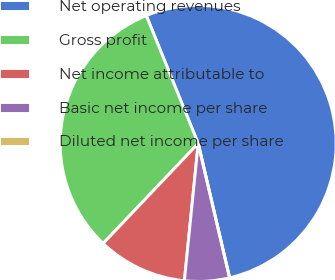<chart> <loc_0><loc_0><loc_500><loc_500><pie_chart><fcel>Net operating revenues<fcel>Gross profit<fcel>Net income attributable to<fcel>Basic net income per share<fcel>Diluted net income per share<nl><fcel>52.48%<fcel>31.77%<fcel>10.5%<fcel>5.25%<fcel>0.0%<nl></chart> 